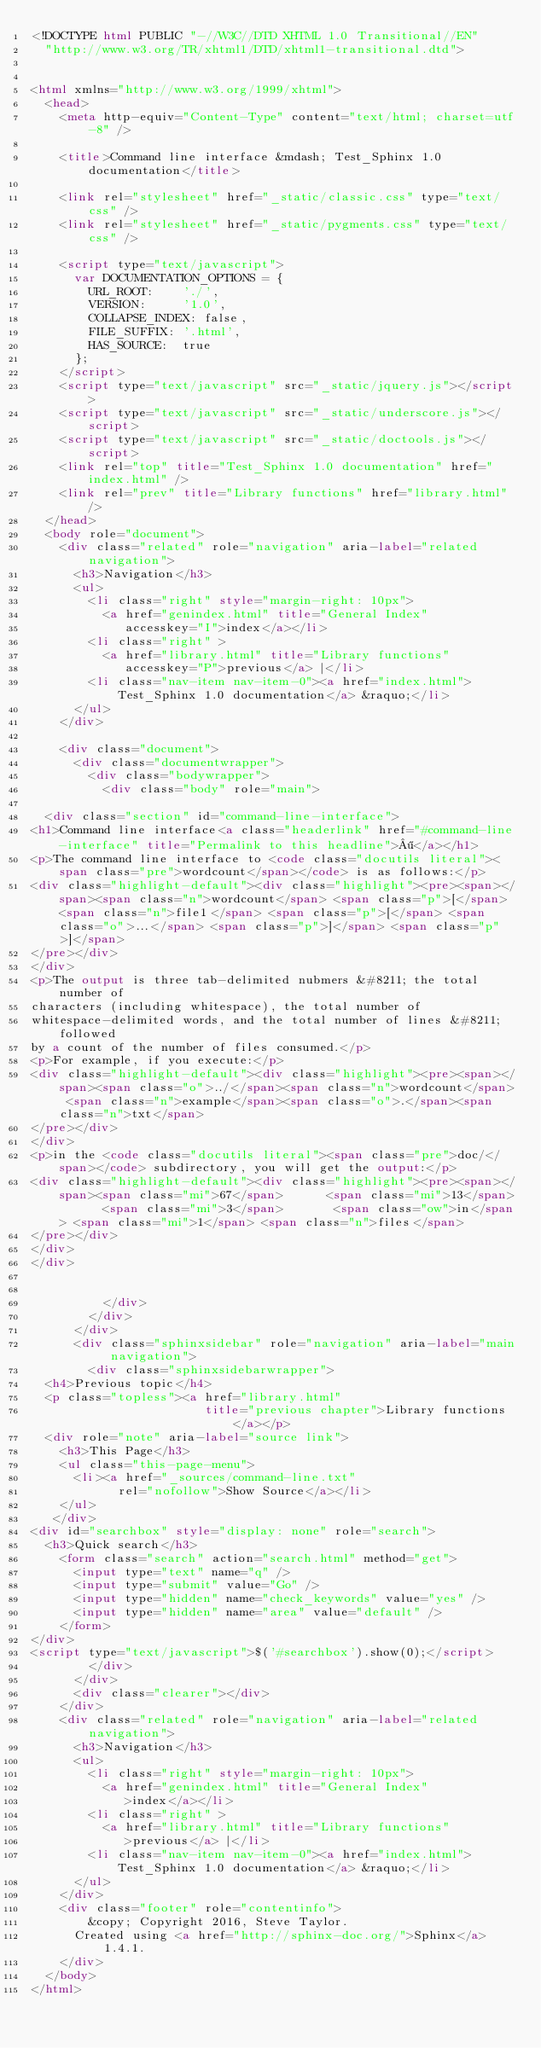<code> <loc_0><loc_0><loc_500><loc_500><_HTML_><!DOCTYPE html PUBLIC "-//W3C//DTD XHTML 1.0 Transitional//EN"
  "http://www.w3.org/TR/xhtml1/DTD/xhtml1-transitional.dtd">


<html xmlns="http://www.w3.org/1999/xhtml">
  <head>
    <meta http-equiv="Content-Type" content="text/html; charset=utf-8" />
    
    <title>Command line interface &mdash; Test_Sphinx 1.0 documentation</title>
    
    <link rel="stylesheet" href="_static/classic.css" type="text/css" />
    <link rel="stylesheet" href="_static/pygments.css" type="text/css" />
    
    <script type="text/javascript">
      var DOCUMENTATION_OPTIONS = {
        URL_ROOT:    './',
        VERSION:     '1.0',
        COLLAPSE_INDEX: false,
        FILE_SUFFIX: '.html',
        HAS_SOURCE:  true
      };
    </script>
    <script type="text/javascript" src="_static/jquery.js"></script>
    <script type="text/javascript" src="_static/underscore.js"></script>
    <script type="text/javascript" src="_static/doctools.js"></script>
    <link rel="top" title="Test_Sphinx 1.0 documentation" href="index.html" />
    <link rel="prev" title="Library functions" href="library.html" /> 
  </head>
  <body role="document">
    <div class="related" role="navigation" aria-label="related navigation">
      <h3>Navigation</h3>
      <ul>
        <li class="right" style="margin-right: 10px">
          <a href="genindex.html" title="General Index"
             accesskey="I">index</a></li>
        <li class="right" >
          <a href="library.html" title="Library functions"
             accesskey="P">previous</a> |</li>
        <li class="nav-item nav-item-0"><a href="index.html">Test_Sphinx 1.0 documentation</a> &raquo;</li> 
      </ul>
    </div>  

    <div class="document">
      <div class="documentwrapper">
        <div class="bodywrapper">
          <div class="body" role="main">
            
  <div class="section" id="command-line-interface">
<h1>Command line interface<a class="headerlink" href="#command-line-interface" title="Permalink to this headline">¶</a></h1>
<p>The command line interface to <code class="docutils literal"><span class="pre">wordcount</span></code> is as follows:</p>
<div class="highlight-default"><div class="highlight"><pre><span></span><span class="n">wordcount</span> <span class="p">[</span> <span class="n">file1</span> <span class="p">[</span> <span class="o">...</span> <span class="p">]</span> <span class="p">]</span>
</pre></div>
</div>
<p>The output is three tab-delimited nubmers &#8211; the total number of
characters (including whitespace), the total number of
whitespace-delimited words, and the total number of lines &#8211; followed
by a count of the number of files consumed.</p>
<p>For example, if you execute:</p>
<div class="highlight-default"><div class="highlight"><pre><span></span><span class="o">../</span><span class="n">wordcount</span> <span class="n">example</span><span class="o">.</span><span class="n">txt</span>
</pre></div>
</div>
<p>in the <code class="docutils literal"><span class="pre">doc/</span></code> subdirectory, you will get the output:</p>
<div class="highlight-default"><div class="highlight"><pre><span></span><span class="mi">67</span>      <span class="mi">13</span>      <span class="mi">3</span>       <span class="ow">in</span> <span class="mi">1</span> <span class="n">files</span>
</pre></div>
</div>
</div>


          </div>
        </div>
      </div>
      <div class="sphinxsidebar" role="navigation" aria-label="main navigation">
        <div class="sphinxsidebarwrapper">
  <h4>Previous topic</h4>
  <p class="topless"><a href="library.html"
                        title="previous chapter">Library functions</a></p>
  <div role="note" aria-label="source link">
    <h3>This Page</h3>
    <ul class="this-page-menu">
      <li><a href="_sources/command-line.txt"
            rel="nofollow">Show Source</a></li>
    </ul>
   </div>
<div id="searchbox" style="display: none" role="search">
  <h3>Quick search</h3>
    <form class="search" action="search.html" method="get">
      <input type="text" name="q" />
      <input type="submit" value="Go" />
      <input type="hidden" name="check_keywords" value="yes" />
      <input type="hidden" name="area" value="default" />
    </form>
</div>
<script type="text/javascript">$('#searchbox').show(0);</script>
        </div>
      </div>
      <div class="clearer"></div>
    </div>
    <div class="related" role="navigation" aria-label="related navigation">
      <h3>Navigation</h3>
      <ul>
        <li class="right" style="margin-right: 10px">
          <a href="genindex.html" title="General Index"
             >index</a></li>
        <li class="right" >
          <a href="library.html" title="Library functions"
             >previous</a> |</li>
        <li class="nav-item nav-item-0"><a href="index.html">Test_Sphinx 1.0 documentation</a> &raquo;</li> 
      </ul>
    </div>
    <div class="footer" role="contentinfo">
        &copy; Copyright 2016, Steve Taylor.
      Created using <a href="http://sphinx-doc.org/">Sphinx</a> 1.4.1.
    </div>
  </body>
</html></code> 